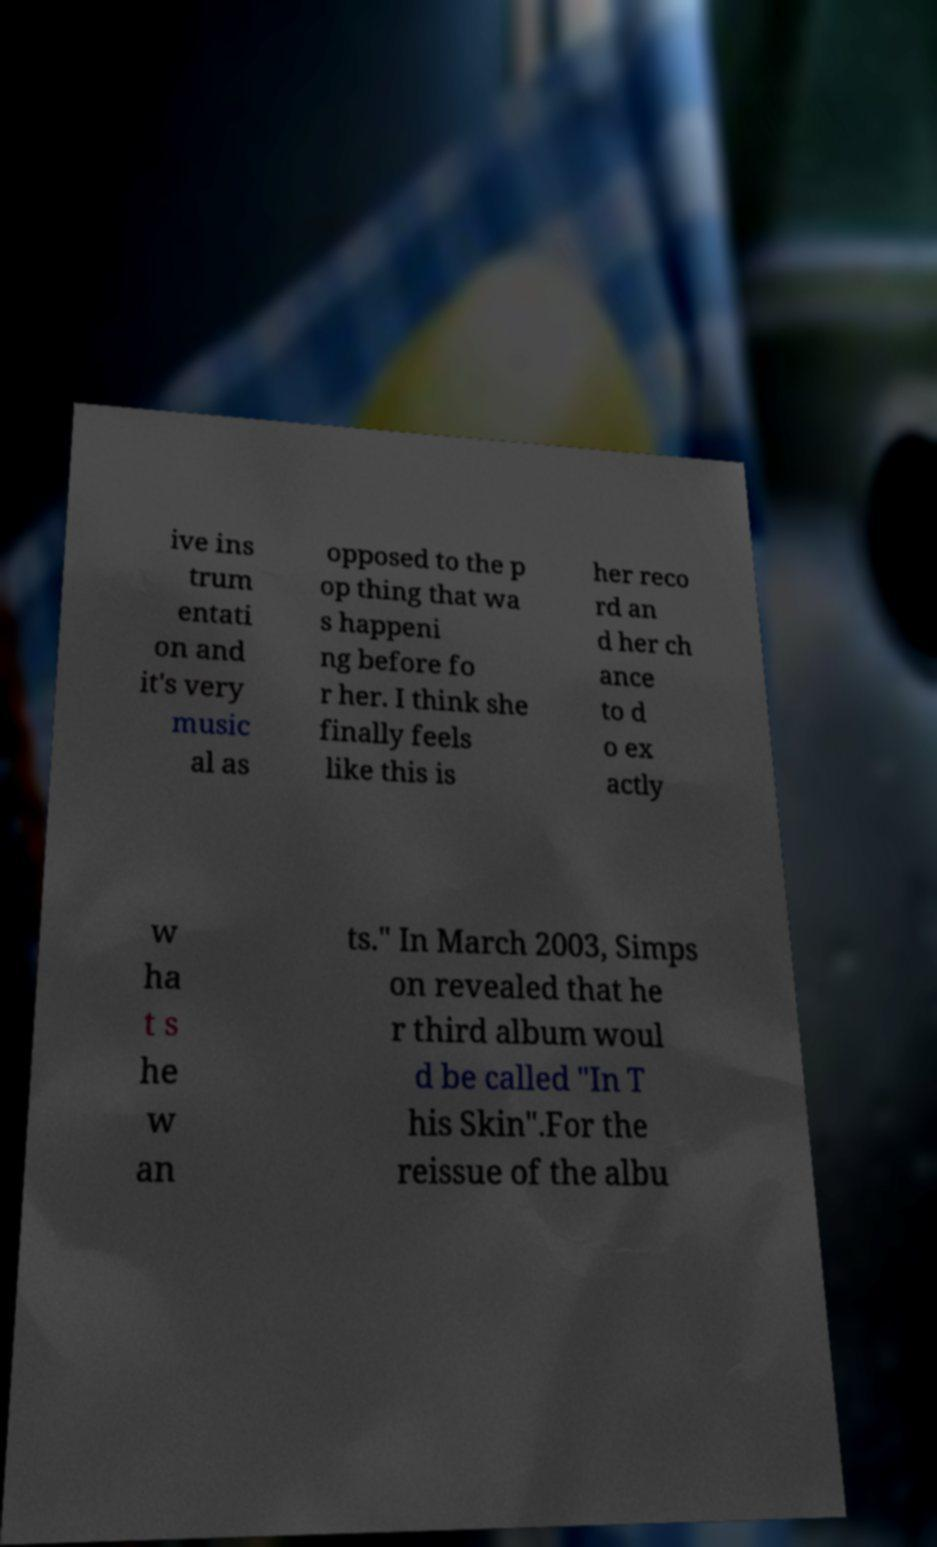Please read and relay the text visible in this image. What does it say? ive ins trum entati on and it's very music al as opposed to the p op thing that wa s happeni ng before fo r her. I think she finally feels like this is her reco rd an d her ch ance to d o ex actly w ha t s he w an ts." In March 2003, Simps on revealed that he r third album woul d be called "In T his Skin".For the reissue of the albu 